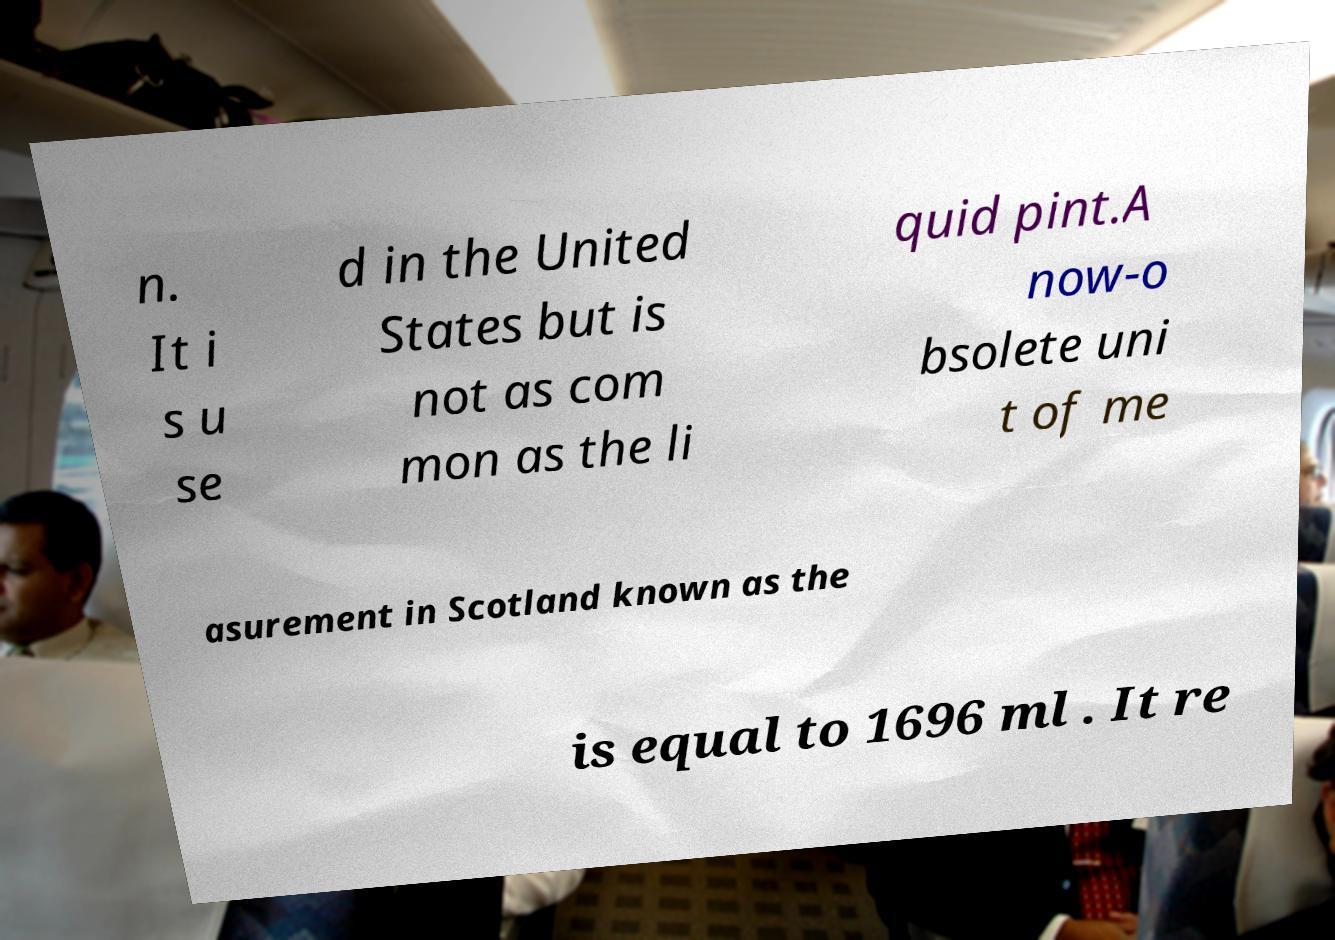For documentation purposes, I need the text within this image transcribed. Could you provide that? n. It i s u se d in the United States but is not as com mon as the li quid pint.A now-o bsolete uni t of me asurement in Scotland known as the is equal to 1696 ml . It re 